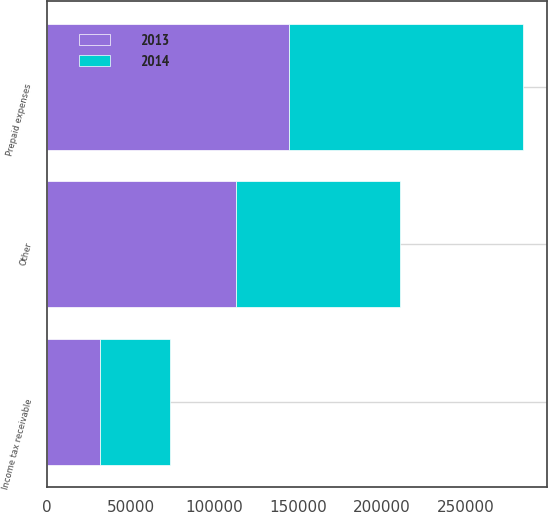Convert chart. <chart><loc_0><loc_0><loc_500><loc_500><stacked_bar_chart><ecel><fcel>Income tax receivable<fcel>Other<fcel>Prepaid expenses<nl><fcel>2013<fcel>31915<fcel>112886<fcel>144801<nl><fcel>2014<fcel>41559<fcel>97910<fcel>139469<nl></chart> 